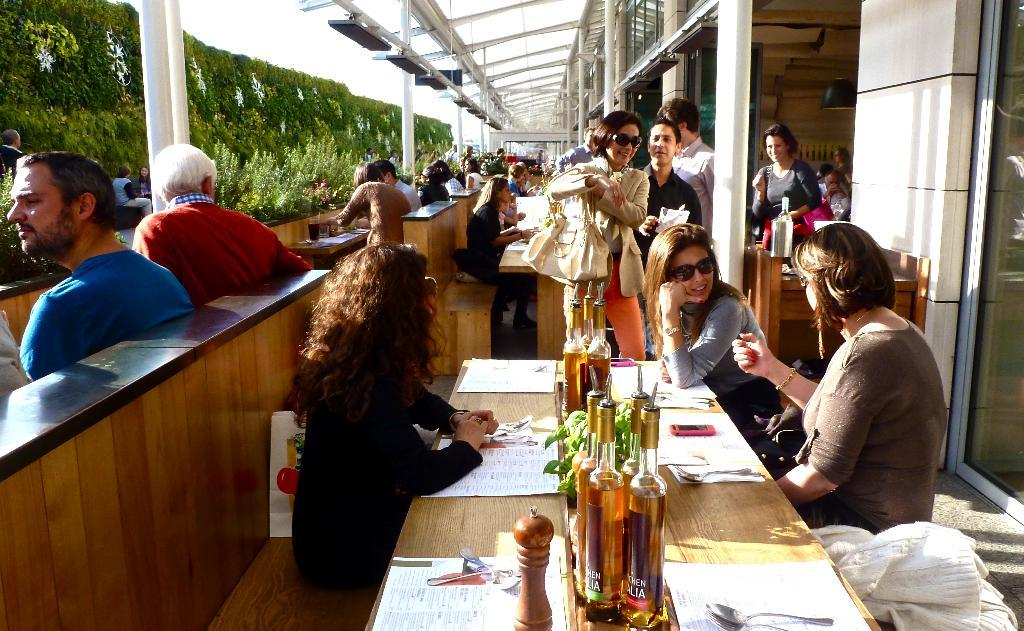What is the main subject of the image? The main subject of the image is a group of people. What are some of the people in the image doing? Some people are standing, while others are seated on benches. What can be seen on the table in the image? There are bottles on a table. What type of vegetation is present in the image? There are plants in the vicinity. What type of honey is being served in the image? There is no honey present in the image. How many umbrellas are being used by the people in the image? There are no umbrellas visible in the image. 